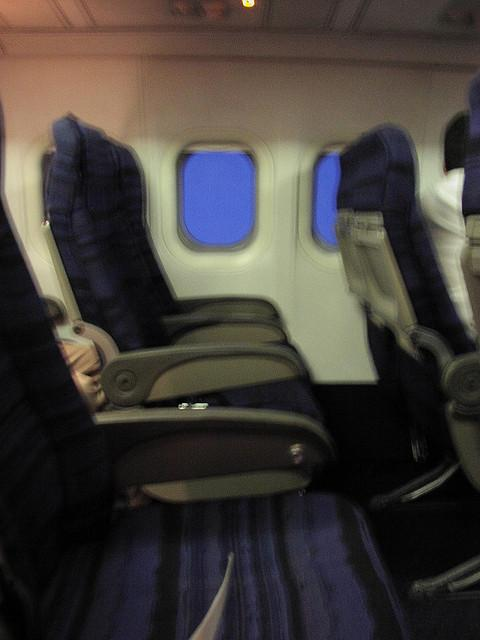Where are the seats placed inside? Please explain your reasoning. airplane. The seats are at an airplane. 